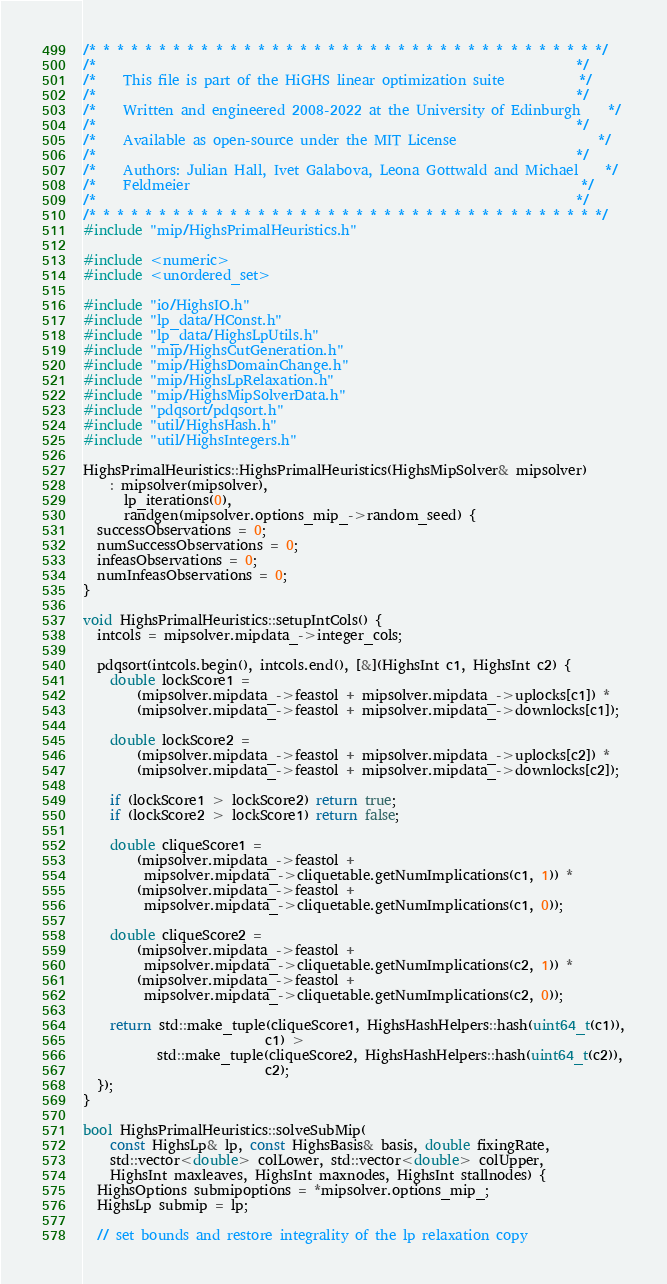Convert code to text. <code><loc_0><loc_0><loc_500><loc_500><_C++_>/* * * * * * * * * * * * * * * * * * * * * * * * * * * * * * * * * * * * */
/*                                                                       */
/*    This file is part of the HiGHS linear optimization suite           */
/*                                                                       */
/*    Written and engineered 2008-2022 at the University of Edinburgh    */
/*                                                                       */
/*    Available as open-source under the MIT License                     */
/*                                                                       */
/*    Authors: Julian Hall, Ivet Galabova, Leona Gottwald and Michael    */
/*    Feldmeier                                                          */
/*                                                                       */
/* * * * * * * * * * * * * * * * * * * * * * * * * * * * * * * * * * * * */
#include "mip/HighsPrimalHeuristics.h"

#include <numeric>
#include <unordered_set>

#include "io/HighsIO.h"
#include "lp_data/HConst.h"
#include "lp_data/HighsLpUtils.h"
#include "mip/HighsCutGeneration.h"
#include "mip/HighsDomainChange.h"
#include "mip/HighsLpRelaxation.h"
#include "mip/HighsMipSolverData.h"
#include "pdqsort/pdqsort.h"
#include "util/HighsHash.h"
#include "util/HighsIntegers.h"

HighsPrimalHeuristics::HighsPrimalHeuristics(HighsMipSolver& mipsolver)
    : mipsolver(mipsolver),
      lp_iterations(0),
      randgen(mipsolver.options_mip_->random_seed) {
  successObservations = 0;
  numSuccessObservations = 0;
  infeasObservations = 0;
  numInfeasObservations = 0;
}

void HighsPrimalHeuristics::setupIntCols() {
  intcols = mipsolver.mipdata_->integer_cols;

  pdqsort(intcols.begin(), intcols.end(), [&](HighsInt c1, HighsInt c2) {
    double lockScore1 =
        (mipsolver.mipdata_->feastol + mipsolver.mipdata_->uplocks[c1]) *
        (mipsolver.mipdata_->feastol + mipsolver.mipdata_->downlocks[c1]);

    double lockScore2 =
        (mipsolver.mipdata_->feastol + mipsolver.mipdata_->uplocks[c2]) *
        (mipsolver.mipdata_->feastol + mipsolver.mipdata_->downlocks[c2]);

    if (lockScore1 > lockScore2) return true;
    if (lockScore2 > lockScore1) return false;

    double cliqueScore1 =
        (mipsolver.mipdata_->feastol +
         mipsolver.mipdata_->cliquetable.getNumImplications(c1, 1)) *
        (mipsolver.mipdata_->feastol +
         mipsolver.mipdata_->cliquetable.getNumImplications(c1, 0));

    double cliqueScore2 =
        (mipsolver.mipdata_->feastol +
         mipsolver.mipdata_->cliquetable.getNumImplications(c2, 1)) *
        (mipsolver.mipdata_->feastol +
         mipsolver.mipdata_->cliquetable.getNumImplications(c2, 0));

    return std::make_tuple(cliqueScore1, HighsHashHelpers::hash(uint64_t(c1)),
                           c1) >
           std::make_tuple(cliqueScore2, HighsHashHelpers::hash(uint64_t(c2)),
                           c2);
  });
}

bool HighsPrimalHeuristics::solveSubMip(
    const HighsLp& lp, const HighsBasis& basis, double fixingRate,
    std::vector<double> colLower, std::vector<double> colUpper,
    HighsInt maxleaves, HighsInt maxnodes, HighsInt stallnodes) {
  HighsOptions submipoptions = *mipsolver.options_mip_;
  HighsLp submip = lp;

  // set bounds and restore integrality of the lp relaxation copy</code> 